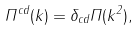<formula> <loc_0><loc_0><loc_500><loc_500>\Pi ^ { c d } ( k ) = \delta _ { c d } \Pi ( k ^ { 2 } ) ,</formula> 